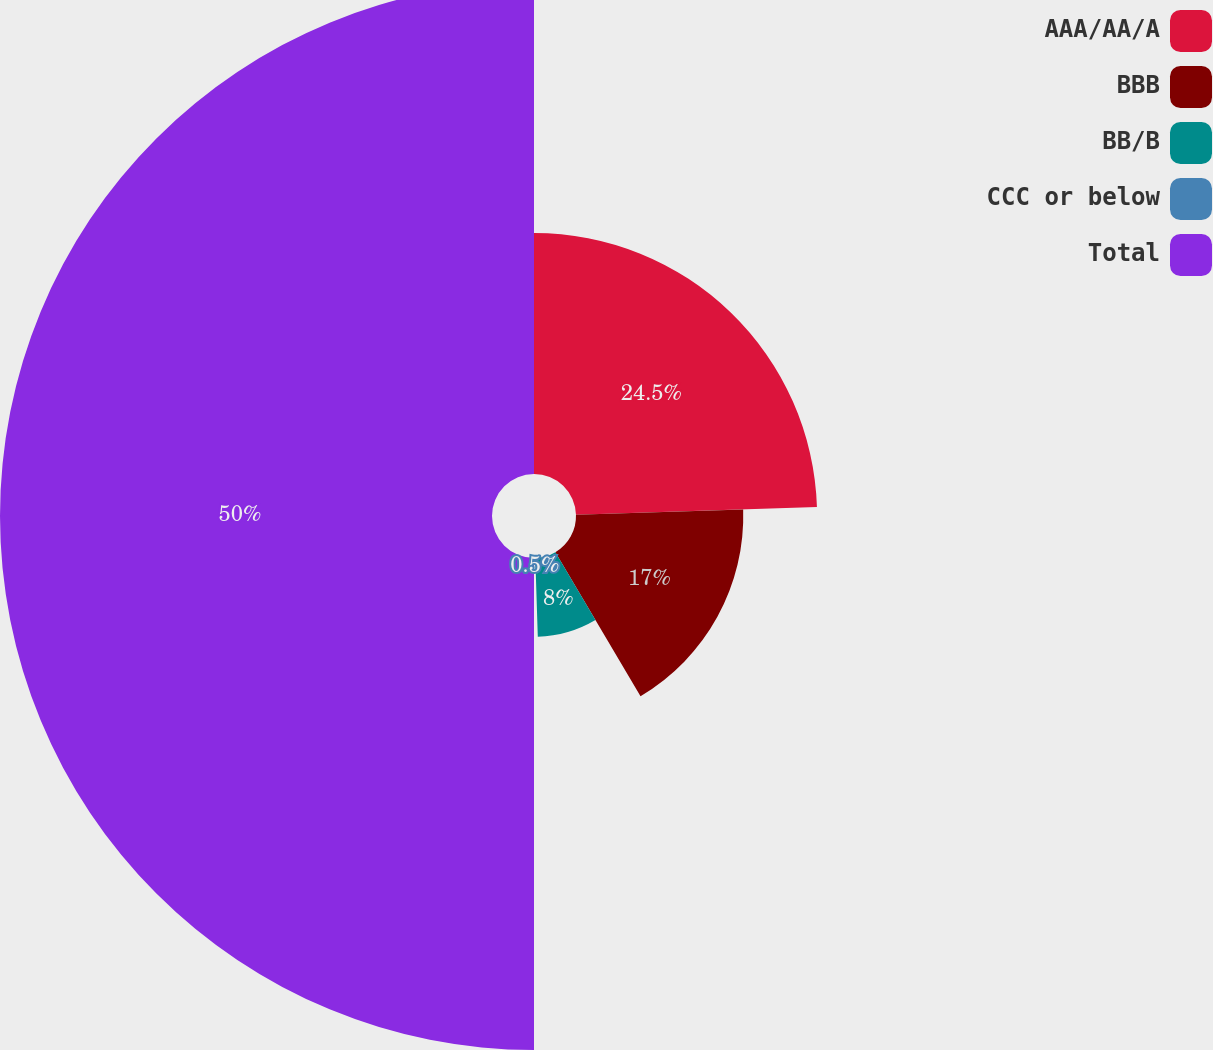Convert chart. <chart><loc_0><loc_0><loc_500><loc_500><pie_chart><fcel>AAA/AA/A<fcel>BBB<fcel>BB/B<fcel>CCC or below<fcel>Total<nl><fcel>24.5%<fcel>17.0%<fcel>8.0%<fcel>0.5%<fcel>50.0%<nl></chart> 